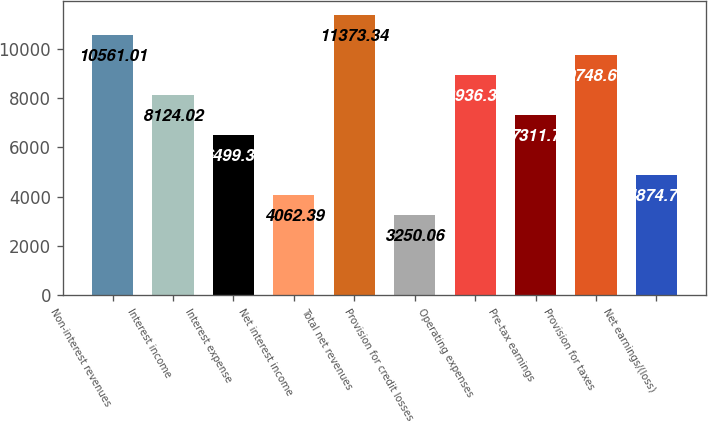<chart> <loc_0><loc_0><loc_500><loc_500><bar_chart><fcel>Non-interest revenues<fcel>Interest income<fcel>Interest expense<fcel>Net interest income<fcel>Total net revenues<fcel>Provision for credit losses<fcel>Operating expenses<fcel>Pre-tax earnings<fcel>Provision for taxes<fcel>Net earnings/(loss)<nl><fcel>10561<fcel>8124.02<fcel>6499.38<fcel>4062.39<fcel>11373.3<fcel>3250.06<fcel>8936.35<fcel>7311.7<fcel>9748.68<fcel>4874.72<nl></chart> 